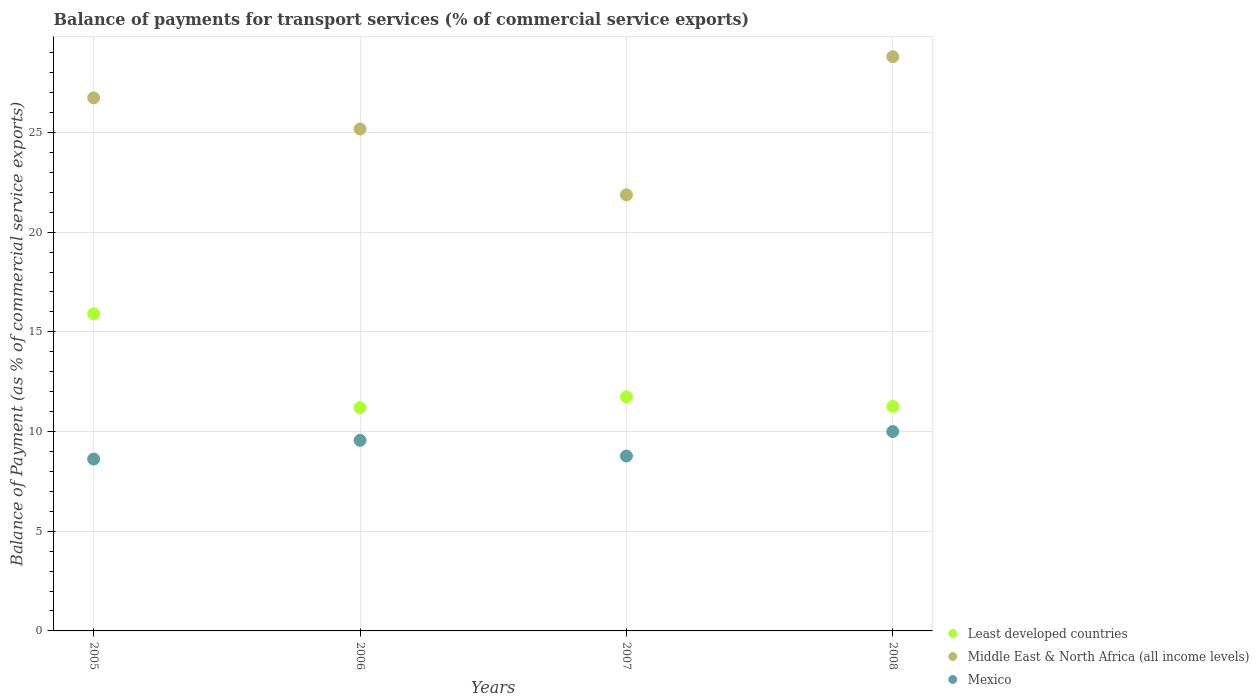What is the balance of payments for transport services in Middle East & North Africa (all income levels) in 2005?
Ensure brevity in your answer.  26.74. Across all years, what is the maximum balance of payments for transport services in Middle East & North Africa (all income levels)?
Offer a terse response. 28.8. Across all years, what is the minimum balance of payments for transport services in Least developed countries?
Your response must be concise. 11.2. What is the total balance of payments for transport services in Least developed countries in the graph?
Provide a short and direct response. 50.11. What is the difference between the balance of payments for transport services in Least developed countries in 2006 and that in 2007?
Make the answer very short. -0.54. What is the difference between the balance of payments for transport services in Middle East & North Africa (all income levels) in 2006 and the balance of payments for transport services in Least developed countries in 2005?
Provide a succinct answer. 9.27. What is the average balance of payments for transport services in Mexico per year?
Keep it short and to the point. 9.24. In the year 2006, what is the difference between the balance of payments for transport services in Mexico and balance of payments for transport services in Least developed countries?
Your response must be concise. -1.64. In how many years, is the balance of payments for transport services in Mexico greater than 2 %?
Provide a short and direct response. 4. What is the ratio of the balance of payments for transport services in Middle East & North Africa (all income levels) in 2005 to that in 2007?
Ensure brevity in your answer.  1.22. What is the difference between the highest and the second highest balance of payments for transport services in Least developed countries?
Your response must be concise. 4.17. What is the difference between the highest and the lowest balance of payments for transport services in Mexico?
Offer a terse response. 1.38. Is the sum of the balance of payments for transport services in Middle East & North Africa (all income levels) in 2007 and 2008 greater than the maximum balance of payments for transport services in Least developed countries across all years?
Offer a very short reply. Yes. Is it the case that in every year, the sum of the balance of payments for transport services in Mexico and balance of payments for transport services in Least developed countries  is greater than the balance of payments for transport services in Middle East & North Africa (all income levels)?
Provide a succinct answer. No. Is the balance of payments for transport services in Middle East & North Africa (all income levels) strictly greater than the balance of payments for transport services in Least developed countries over the years?
Your response must be concise. Yes. Is the balance of payments for transport services in Mexico strictly less than the balance of payments for transport services in Least developed countries over the years?
Keep it short and to the point. Yes. What is the difference between two consecutive major ticks on the Y-axis?
Your answer should be compact. 5. Are the values on the major ticks of Y-axis written in scientific E-notation?
Make the answer very short. No. Does the graph contain any zero values?
Offer a very short reply. No. Where does the legend appear in the graph?
Give a very brief answer. Bottom right. What is the title of the graph?
Ensure brevity in your answer.  Balance of payments for transport services (% of commercial service exports). Does "Mexico" appear as one of the legend labels in the graph?
Your response must be concise. Yes. What is the label or title of the Y-axis?
Offer a terse response. Balance of Payment (as % of commercial service exports). What is the Balance of Payment (as % of commercial service exports) of Least developed countries in 2005?
Your response must be concise. 15.91. What is the Balance of Payment (as % of commercial service exports) of Middle East & North Africa (all income levels) in 2005?
Your answer should be compact. 26.74. What is the Balance of Payment (as % of commercial service exports) in Mexico in 2005?
Keep it short and to the point. 8.62. What is the Balance of Payment (as % of commercial service exports) in Least developed countries in 2006?
Ensure brevity in your answer.  11.2. What is the Balance of Payment (as % of commercial service exports) of Middle East & North Africa (all income levels) in 2006?
Provide a succinct answer. 25.18. What is the Balance of Payment (as % of commercial service exports) of Mexico in 2006?
Offer a very short reply. 9.56. What is the Balance of Payment (as % of commercial service exports) in Least developed countries in 2007?
Your answer should be very brief. 11.74. What is the Balance of Payment (as % of commercial service exports) of Middle East & North Africa (all income levels) in 2007?
Make the answer very short. 21.87. What is the Balance of Payment (as % of commercial service exports) in Mexico in 2007?
Your answer should be compact. 8.77. What is the Balance of Payment (as % of commercial service exports) in Least developed countries in 2008?
Offer a very short reply. 11.26. What is the Balance of Payment (as % of commercial service exports) in Middle East & North Africa (all income levels) in 2008?
Provide a short and direct response. 28.8. What is the Balance of Payment (as % of commercial service exports) in Mexico in 2008?
Make the answer very short. 10. Across all years, what is the maximum Balance of Payment (as % of commercial service exports) in Least developed countries?
Provide a succinct answer. 15.91. Across all years, what is the maximum Balance of Payment (as % of commercial service exports) of Middle East & North Africa (all income levels)?
Make the answer very short. 28.8. Across all years, what is the maximum Balance of Payment (as % of commercial service exports) of Mexico?
Provide a short and direct response. 10. Across all years, what is the minimum Balance of Payment (as % of commercial service exports) of Least developed countries?
Keep it short and to the point. 11.2. Across all years, what is the minimum Balance of Payment (as % of commercial service exports) in Middle East & North Africa (all income levels)?
Keep it short and to the point. 21.87. Across all years, what is the minimum Balance of Payment (as % of commercial service exports) of Mexico?
Make the answer very short. 8.62. What is the total Balance of Payment (as % of commercial service exports) of Least developed countries in the graph?
Offer a terse response. 50.11. What is the total Balance of Payment (as % of commercial service exports) in Middle East & North Africa (all income levels) in the graph?
Make the answer very short. 102.59. What is the total Balance of Payment (as % of commercial service exports) of Mexico in the graph?
Keep it short and to the point. 36.95. What is the difference between the Balance of Payment (as % of commercial service exports) of Least developed countries in 2005 and that in 2006?
Provide a succinct answer. 4.71. What is the difference between the Balance of Payment (as % of commercial service exports) in Middle East & North Africa (all income levels) in 2005 and that in 2006?
Your answer should be compact. 1.56. What is the difference between the Balance of Payment (as % of commercial service exports) in Mexico in 2005 and that in 2006?
Provide a succinct answer. -0.94. What is the difference between the Balance of Payment (as % of commercial service exports) in Least developed countries in 2005 and that in 2007?
Make the answer very short. 4.17. What is the difference between the Balance of Payment (as % of commercial service exports) of Middle East & North Africa (all income levels) in 2005 and that in 2007?
Offer a terse response. 4.86. What is the difference between the Balance of Payment (as % of commercial service exports) in Mexico in 2005 and that in 2007?
Ensure brevity in your answer.  -0.15. What is the difference between the Balance of Payment (as % of commercial service exports) of Least developed countries in 2005 and that in 2008?
Provide a short and direct response. 4.64. What is the difference between the Balance of Payment (as % of commercial service exports) in Middle East & North Africa (all income levels) in 2005 and that in 2008?
Your answer should be compact. -2.07. What is the difference between the Balance of Payment (as % of commercial service exports) of Mexico in 2005 and that in 2008?
Offer a very short reply. -1.38. What is the difference between the Balance of Payment (as % of commercial service exports) in Least developed countries in 2006 and that in 2007?
Your response must be concise. -0.54. What is the difference between the Balance of Payment (as % of commercial service exports) of Middle East & North Africa (all income levels) in 2006 and that in 2007?
Give a very brief answer. 3.3. What is the difference between the Balance of Payment (as % of commercial service exports) in Mexico in 2006 and that in 2007?
Your answer should be compact. 0.78. What is the difference between the Balance of Payment (as % of commercial service exports) of Least developed countries in 2006 and that in 2008?
Your answer should be compact. -0.06. What is the difference between the Balance of Payment (as % of commercial service exports) in Middle East & North Africa (all income levels) in 2006 and that in 2008?
Your answer should be very brief. -3.63. What is the difference between the Balance of Payment (as % of commercial service exports) of Mexico in 2006 and that in 2008?
Provide a succinct answer. -0.44. What is the difference between the Balance of Payment (as % of commercial service exports) of Least developed countries in 2007 and that in 2008?
Provide a short and direct response. 0.48. What is the difference between the Balance of Payment (as % of commercial service exports) of Middle East & North Africa (all income levels) in 2007 and that in 2008?
Your answer should be very brief. -6.93. What is the difference between the Balance of Payment (as % of commercial service exports) in Mexico in 2007 and that in 2008?
Your response must be concise. -1.23. What is the difference between the Balance of Payment (as % of commercial service exports) of Least developed countries in 2005 and the Balance of Payment (as % of commercial service exports) of Middle East & North Africa (all income levels) in 2006?
Provide a short and direct response. -9.27. What is the difference between the Balance of Payment (as % of commercial service exports) of Least developed countries in 2005 and the Balance of Payment (as % of commercial service exports) of Mexico in 2006?
Make the answer very short. 6.35. What is the difference between the Balance of Payment (as % of commercial service exports) in Middle East & North Africa (all income levels) in 2005 and the Balance of Payment (as % of commercial service exports) in Mexico in 2006?
Your answer should be compact. 17.18. What is the difference between the Balance of Payment (as % of commercial service exports) in Least developed countries in 2005 and the Balance of Payment (as % of commercial service exports) in Middle East & North Africa (all income levels) in 2007?
Offer a terse response. -5.97. What is the difference between the Balance of Payment (as % of commercial service exports) in Least developed countries in 2005 and the Balance of Payment (as % of commercial service exports) in Mexico in 2007?
Offer a very short reply. 7.13. What is the difference between the Balance of Payment (as % of commercial service exports) in Middle East & North Africa (all income levels) in 2005 and the Balance of Payment (as % of commercial service exports) in Mexico in 2007?
Give a very brief answer. 17.96. What is the difference between the Balance of Payment (as % of commercial service exports) of Least developed countries in 2005 and the Balance of Payment (as % of commercial service exports) of Middle East & North Africa (all income levels) in 2008?
Offer a terse response. -12.9. What is the difference between the Balance of Payment (as % of commercial service exports) of Least developed countries in 2005 and the Balance of Payment (as % of commercial service exports) of Mexico in 2008?
Provide a succinct answer. 5.9. What is the difference between the Balance of Payment (as % of commercial service exports) of Middle East & North Africa (all income levels) in 2005 and the Balance of Payment (as % of commercial service exports) of Mexico in 2008?
Your response must be concise. 16.74. What is the difference between the Balance of Payment (as % of commercial service exports) in Least developed countries in 2006 and the Balance of Payment (as % of commercial service exports) in Middle East & North Africa (all income levels) in 2007?
Make the answer very short. -10.67. What is the difference between the Balance of Payment (as % of commercial service exports) of Least developed countries in 2006 and the Balance of Payment (as % of commercial service exports) of Mexico in 2007?
Provide a short and direct response. 2.43. What is the difference between the Balance of Payment (as % of commercial service exports) in Middle East & North Africa (all income levels) in 2006 and the Balance of Payment (as % of commercial service exports) in Mexico in 2007?
Keep it short and to the point. 16.4. What is the difference between the Balance of Payment (as % of commercial service exports) in Least developed countries in 2006 and the Balance of Payment (as % of commercial service exports) in Middle East & North Africa (all income levels) in 2008?
Provide a short and direct response. -17.6. What is the difference between the Balance of Payment (as % of commercial service exports) of Least developed countries in 2006 and the Balance of Payment (as % of commercial service exports) of Mexico in 2008?
Give a very brief answer. 1.2. What is the difference between the Balance of Payment (as % of commercial service exports) in Middle East & North Africa (all income levels) in 2006 and the Balance of Payment (as % of commercial service exports) in Mexico in 2008?
Your response must be concise. 15.17. What is the difference between the Balance of Payment (as % of commercial service exports) in Least developed countries in 2007 and the Balance of Payment (as % of commercial service exports) in Middle East & North Africa (all income levels) in 2008?
Your answer should be very brief. -17.06. What is the difference between the Balance of Payment (as % of commercial service exports) in Least developed countries in 2007 and the Balance of Payment (as % of commercial service exports) in Mexico in 2008?
Ensure brevity in your answer.  1.74. What is the difference between the Balance of Payment (as % of commercial service exports) of Middle East & North Africa (all income levels) in 2007 and the Balance of Payment (as % of commercial service exports) of Mexico in 2008?
Your response must be concise. 11.87. What is the average Balance of Payment (as % of commercial service exports) in Least developed countries per year?
Keep it short and to the point. 12.53. What is the average Balance of Payment (as % of commercial service exports) in Middle East & North Africa (all income levels) per year?
Offer a terse response. 25.65. What is the average Balance of Payment (as % of commercial service exports) in Mexico per year?
Provide a short and direct response. 9.24. In the year 2005, what is the difference between the Balance of Payment (as % of commercial service exports) in Least developed countries and Balance of Payment (as % of commercial service exports) in Middle East & North Africa (all income levels)?
Give a very brief answer. -10.83. In the year 2005, what is the difference between the Balance of Payment (as % of commercial service exports) in Least developed countries and Balance of Payment (as % of commercial service exports) in Mexico?
Ensure brevity in your answer.  7.29. In the year 2005, what is the difference between the Balance of Payment (as % of commercial service exports) in Middle East & North Africa (all income levels) and Balance of Payment (as % of commercial service exports) in Mexico?
Make the answer very short. 18.12. In the year 2006, what is the difference between the Balance of Payment (as % of commercial service exports) of Least developed countries and Balance of Payment (as % of commercial service exports) of Middle East & North Africa (all income levels)?
Offer a very short reply. -13.98. In the year 2006, what is the difference between the Balance of Payment (as % of commercial service exports) in Least developed countries and Balance of Payment (as % of commercial service exports) in Mexico?
Your response must be concise. 1.64. In the year 2006, what is the difference between the Balance of Payment (as % of commercial service exports) in Middle East & North Africa (all income levels) and Balance of Payment (as % of commercial service exports) in Mexico?
Ensure brevity in your answer.  15.62. In the year 2007, what is the difference between the Balance of Payment (as % of commercial service exports) of Least developed countries and Balance of Payment (as % of commercial service exports) of Middle East & North Africa (all income levels)?
Keep it short and to the point. -10.13. In the year 2007, what is the difference between the Balance of Payment (as % of commercial service exports) in Least developed countries and Balance of Payment (as % of commercial service exports) in Mexico?
Provide a succinct answer. 2.97. In the year 2007, what is the difference between the Balance of Payment (as % of commercial service exports) in Middle East & North Africa (all income levels) and Balance of Payment (as % of commercial service exports) in Mexico?
Give a very brief answer. 13.1. In the year 2008, what is the difference between the Balance of Payment (as % of commercial service exports) of Least developed countries and Balance of Payment (as % of commercial service exports) of Middle East & North Africa (all income levels)?
Your answer should be very brief. -17.54. In the year 2008, what is the difference between the Balance of Payment (as % of commercial service exports) of Least developed countries and Balance of Payment (as % of commercial service exports) of Mexico?
Give a very brief answer. 1.26. In the year 2008, what is the difference between the Balance of Payment (as % of commercial service exports) in Middle East & North Africa (all income levels) and Balance of Payment (as % of commercial service exports) in Mexico?
Your answer should be compact. 18.8. What is the ratio of the Balance of Payment (as % of commercial service exports) in Least developed countries in 2005 to that in 2006?
Your answer should be very brief. 1.42. What is the ratio of the Balance of Payment (as % of commercial service exports) of Middle East & North Africa (all income levels) in 2005 to that in 2006?
Keep it short and to the point. 1.06. What is the ratio of the Balance of Payment (as % of commercial service exports) of Mexico in 2005 to that in 2006?
Give a very brief answer. 0.9. What is the ratio of the Balance of Payment (as % of commercial service exports) of Least developed countries in 2005 to that in 2007?
Give a very brief answer. 1.35. What is the ratio of the Balance of Payment (as % of commercial service exports) of Middle East & North Africa (all income levels) in 2005 to that in 2007?
Keep it short and to the point. 1.22. What is the ratio of the Balance of Payment (as % of commercial service exports) in Mexico in 2005 to that in 2007?
Make the answer very short. 0.98. What is the ratio of the Balance of Payment (as % of commercial service exports) in Least developed countries in 2005 to that in 2008?
Ensure brevity in your answer.  1.41. What is the ratio of the Balance of Payment (as % of commercial service exports) in Middle East & North Africa (all income levels) in 2005 to that in 2008?
Keep it short and to the point. 0.93. What is the ratio of the Balance of Payment (as % of commercial service exports) in Mexico in 2005 to that in 2008?
Your response must be concise. 0.86. What is the ratio of the Balance of Payment (as % of commercial service exports) of Least developed countries in 2006 to that in 2007?
Offer a very short reply. 0.95. What is the ratio of the Balance of Payment (as % of commercial service exports) of Middle East & North Africa (all income levels) in 2006 to that in 2007?
Your answer should be compact. 1.15. What is the ratio of the Balance of Payment (as % of commercial service exports) in Mexico in 2006 to that in 2007?
Provide a short and direct response. 1.09. What is the ratio of the Balance of Payment (as % of commercial service exports) in Least developed countries in 2006 to that in 2008?
Make the answer very short. 0.99. What is the ratio of the Balance of Payment (as % of commercial service exports) of Middle East & North Africa (all income levels) in 2006 to that in 2008?
Ensure brevity in your answer.  0.87. What is the ratio of the Balance of Payment (as % of commercial service exports) of Mexico in 2006 to that in 2008?
Give a very brief answer. 0.96. What is the ratio of the Balance of Payment (as % of commercial service exports) in Least developed countries in 2007 to that in 2008?
Provide a short and direct response. 1.04. What is the ratio of the Balance of Payment (as % of commercial service exports) in Middle East & North Africa (all income levels) in 2007 to that in 2008?
Provide a short and direct response. 0.76. What is the ratio of the Balance of Payment (as % of commercial service exports) of Mexico in 2007 to that in 2008?
Your response must be concise. 0.88. What is the difference between the highest and the second highest Balance of Payment (as % of commercial service exports) of Least developed countries?
Ensure brevity in your answer.  4.17. What is the difference between the highest and the second highest Balance of Payment (as % of commercial service exports) of Middle East & North Africa (all income levels)?
Keep it short and to the point. 2.07. What is the difference between the highest and the second highest Balance of Payment (as % of commercial service exports) in Mexico?
Offer a terse response. 0.44. What is the difference between the highest and the lowest Balance of Payment (as % of commercial service exports) in Least developed countries?
Ensure brevity in your answer.  4.71. What is the difference between the highest and the lowest Balance of Payment (as % of commercial service exports) in Middle East & North Africa (all income levels)?
Make the answer very short. 6.93. What is the difference between the highest and the lowest Balance of Payment (as % of commercial service exports) of Mexico?
Make the answer very short. 1.38. 